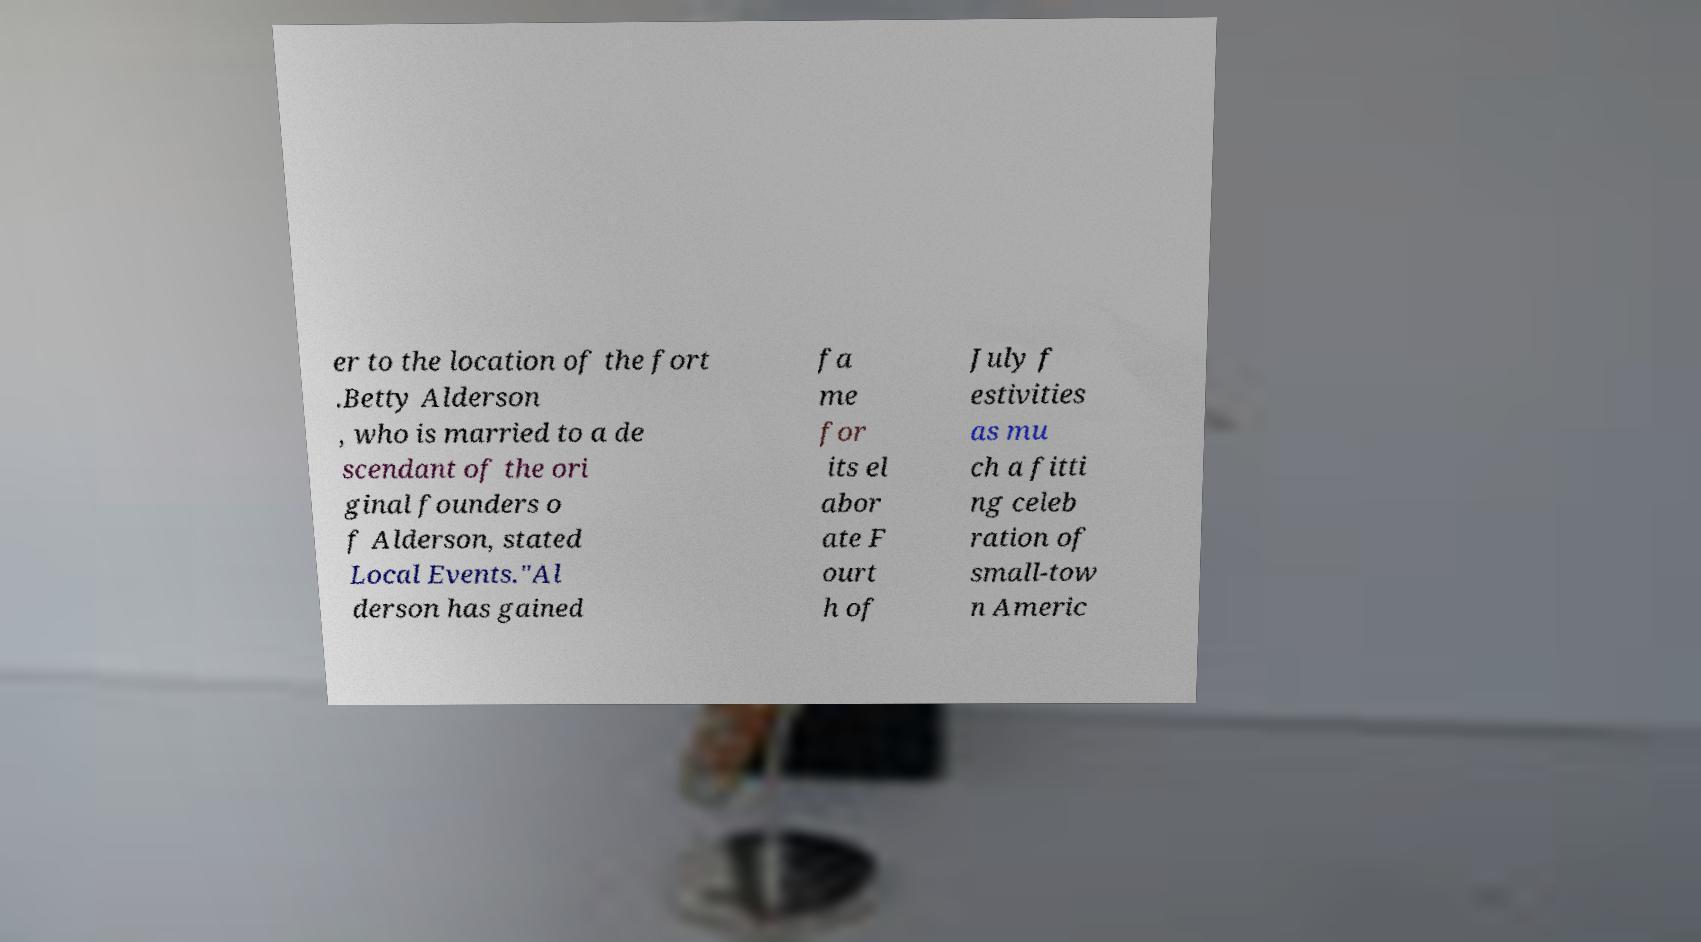Please identify and transcribe the text found in this image. er to the location of the fort .Betty Alderson , who is married to a de scendant of the ori ginal founders o f Alderson, stated Local Events."Al derson has gained fa me for its el abor ate F ourt h of July f estivities as mu ch a fitti ng celeb ration of small-tow n Americ 